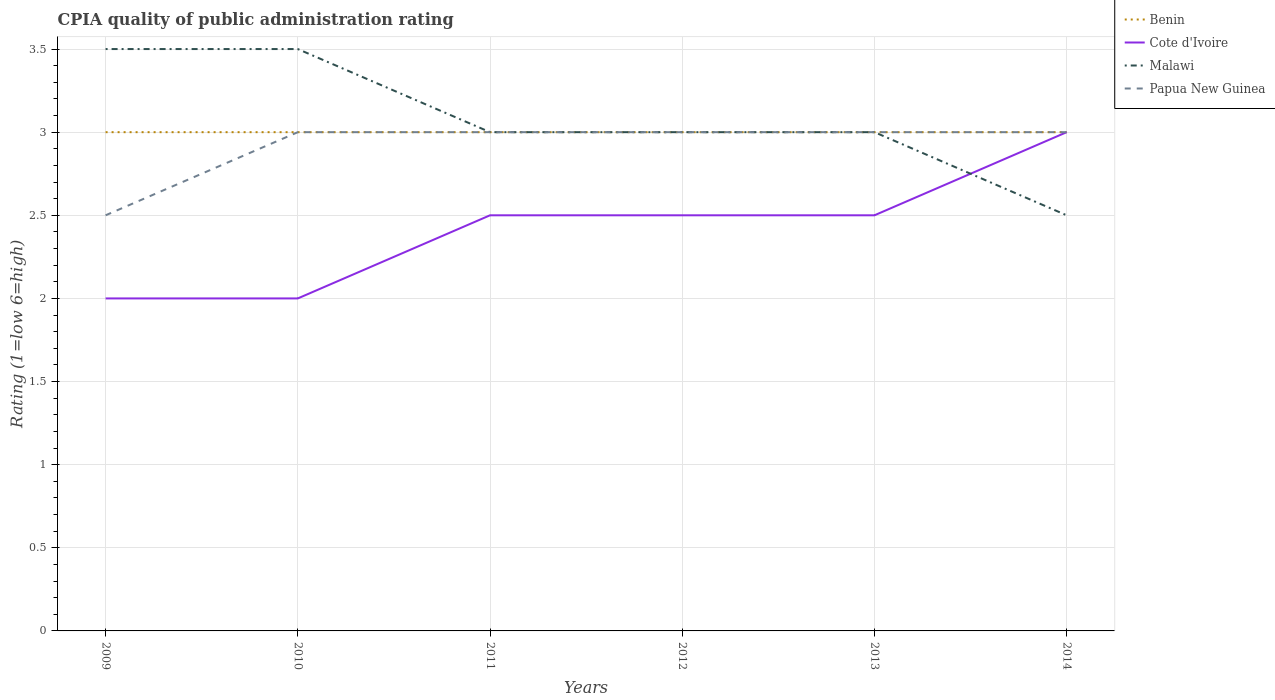How many different coloured lines are there?
Ensure brevity in your answer.  4. Does the line corresponding to Benin intersect with the line corresponding to Papua New Guinea?
Your answer should be compact. Yes. Across all years, what is the maximum CPIA rating in Cote d'Ivoire?
Offer a terse response. 2. In which year was the CPIA rating in Cote d'Ivoire maximum?
Provide a short and direct response. 2009. What is the total CPIA rating in Cote d'Ivoire in the graph?
Keep it short and to the point. -0.5. What is the difference between the highest and the lowest CPIA rating in Papua New Guinea?
Provide a short and direct response. 5. Is the CPIA rating in Papua New Guinea strictly greater than the CPIA rating in Malawi over the years?
Your response must be concise. No. How many lines are there?
Make the answer very short. 4. What is the difference between two consecutive major ticks on the Y-axis?
Your answer should be compact. 0.5. Does the graph contain grids?
Offer a terse response. Yes. Where does the legend appear in the graph?
Keep it short and to the point. Top right. How are the legend labels stacked?
Give a very brief answer. Vertical. What is the title of the graph?
Offer a terse response. CPIA quality of public administration rating. Does "United Arab Emirates" appear as one of the legend labels in the graph?
Provide a succinct answer. No. What is the label or title of the Y-axis?
Your answer should be compact. Rating (1=low 6=high). What is the Rating (1=low 6=high) of Malawi in 2009?
Provide a succinct answer. 3.5. What is the Rating (1=low 6=high) in Benin in 2010?
Offer a terse response. 3. What is the Rating (1=low 6=high) of Malawi in 2010?
Provide a short and direct response. 3.5. What is the Rating (1=low 6=high) in Papua New Guinea in 2010?
Ensure brevity in your answer.  3. What is the Rating (1=low 6=high) in Cote d'Ivoire in 2011?
Keep it short and to the point. 2.5. What is the Rating (1=low 6=high) of Cote d'Ivoire in 2012?
Ensure brevity in your answer.  2.5. What is the Rating (1=low 6=high) of Papua New Guinea in 2012?
Ensure brevity in your answer.  3. What is the Rating (1=low 6=high) in Papua New Guinea in 2013?
Make the answer very short. 3. What is the Rating (1=low 6=high) of Cote d'Ivoire in 2014?
Offer a terse response. 3. What is the Rating (1=low 6=high) in Malawi in 2014?
Your response must be concise. 2.5. What is the Rating (1=low 6=high) of Papua New Guinea in 2014?
Keep it short and to the point. 3. Across all years, what is the maximum Rating (1=low 6=high) in Benin?
Make the answer very short. 3. Across all years, what is the maximum Rating (1=low 6=high) of Cote d'Ivoire?
Your response must be concise. 3. Across all years, what is the maximum Rating (1=low 6=high) in Malawi?
Keep it short and to the point. 3.5. Across all years, what is the maximum Rating (1=low 6=high) of Papua New Guinea?
Your response must be concise. 3. Across all years, what is the minimum Rating (1=low 6=high) of Benin?
Make the answer very short. 3. Across all years, what is the minimum Rating (1=low 6=high) in Malawi?
Your response must be concise. 2.5. What is the total Rating (1=low 6=high) of Papua New Guinea in the graph?
Provide a short and direct response. 17.5. What is the difference between the Rating (1=low 6=high) in Cote d'Ivoire in 2009 and that in 2010?
Ensure brevity in your answer.  0. What is the difference between the Rating (1=low 6=high) of Malawi in 2009 and that in 2010?
Give a very brief answer. 0. What is the difference between the Rating (1=low 6=high) of Malawi in 2009 and that in 2012?
Keep it short and to the point. 0.5. What is the difference between the Rating (1=low 6=high) in Papua New Guinea in 2009 and that in 2012?
Make the answer very short. -0.5. What is the difference between the Rating (1=low 6=high) of Cote d'Ivoire in 2009 and that in 2013?
Ensure brevity in your answer.  -0.5. What is the difference between the Rating (1=low 6=high) in Malawi in 2009 and that in 2013?
Offer a very short reply. 0.5. What is the difference between the Rating (1=low 6=high) in Papua New Guinea in 2009 and that in 2013?
Provide a succinct answer. -0.5. What is the difference between the Rating (1=low 6=high) in Benin in 2009 and that in 2014?
Offer a very short reply. 0. What is the difference between the Rating (1=low 6=high) in Cote d'Ivoire in 2009 and that in 2014?
Make the answer very short. -1. What is the difference between the Rating (1=low 6=high) in Papua New Guinea in 2009 and that in 2014?
Ensure brevity in your answer.  -0.5. What is the difference between the Rating (1=low 6=high) of Benin in 2010 and that in 2011?
Offer a terse response. 0. What is the difference between the Rating (1=low 6=high) in Cote d'Ivoire in 2010 and that in 2011?
Your answer should be very brief. -0.5. What is the difference between the Rating (1=low 6=high) of Malawi in 2010 and that in 2011?
Your answer should be compact. 0.5. What is the difference between the Rating (1=low 6=high) in Cote d'Ivoire in 2010 and that in 2012?
Your answer should be compact. -0.5. What is the difference between the Rating (1=low 6=high) of Papua New Guinea in 2010 and that in 2012?
Keep it short and to the point. 0. What is the difference between the Rating (1=low 6=high) in Benin in 2010 and that in 2013?
Provide a short and direct response. 0. What is the difference between the Rating (1=low 6=high) of Malawi in 2010 and that in 2013?
Provide a short and direct response. 0.5. What is the difference between the Rating (1=low 6=high) in Papua New Guinea in 2010 and that in 2013?
Make the answer very short. 0. What is the difference between the Rating (1=low 6=high) in Benin in 2010 and that in 2014?
Your answer should be compact. 0. What is the difference between the Rating (1=low 6=high) of Cote d'Ivoire in 2010 and that in 2014?
Ensure brevity in your answer.  -1. What is the difference between the Rating (1=low 6=high) in Papua New Guinea in 2010 and that in 2014?
Keep it short and to the point. 0. What is the difference between the Rating (1=low 6=high) in Malawi in 2011 and that in 2012?
Offer a terse response. 0. What is the difference between the Rating (1=low 6=high) of Papua New Guinea in 2011 and that in 2012?
Provide a short and direct response. 0. What is the difference between the Rating (1=low 6=high) in Benin in 2011 and that in 2013?
Provide a short and direct response. 0. What is the difference between the Rating (1=low 6=high) in Cote d'Ivoire in 2011 and that in 2013?
Offer a very short reply. 0. What is the difference between the Rating (1=low 6=high) in Papua New Guinea in 2011 and that in 2013?
Give a very brief answer. 0. What is the difference between the Rating (1=low 6=high) in Benin in 2011 and that in 2014?
Make the answer very short. 0. What is the difference between the Rating (1=low 6=high) in Papua New Guinea in 2011 and that in 2014?
Your answer should be very brief. 0. What is the difference between the Rating (1=low 6=high) in Cote d'Ivoire in 2012 and that in 2014?
Your response must be concise. -0.5. What is the difference between the Rating (1=low 6=high) in Malawi in 2012 and that in 2014?
Ensure brevity in your answer.  0.5. What is the difference between the Rating (1=low 6=high) of Cote d'Ivoire in 2013 and that in 2014?
Your response must be concise. -0.5. What is the difference between the Rating (1=low 6=high) of Malawi in 2013 and that in 2014?
Keep it short and to the point. 0.5. What is the difference between the Rating (1=low 6=high) of Papua New Guinea in 2013 and that in 2014?
Offer a terse response. 0. What is the difference between the Rating (1=low 6=high) of Benin in 2009 and the Rating (1=low 6=high) of Cote d'Ivoire in 2010?
Offer a very short reply. 1. What is the difference between the Rating (1=low 6=high) in Benin in 2009 and the Rating (1=low 6=high) in Malawi in 2010?
Offer a terse response. -0.5. What is the difference between the Rating (1=low 6=high) of Benin in 2009 and the Rating (1=low 6=high) of Papua New Guinea in 2010?
Give a very brief answer. 0. What is the difference between the Rating (1=low 6=high) of Cote d'Ivoire in 2009 and the Rating (1=low 6=high) of Papua New Guinea in 2010?
Provide a succinct answer. -1. What is the difference between the Rating (1=low 6=high) of Malawi in 2009 and the Rating (1=low 6=high) of Papua New Guinea in 2010?
Offer a terse response. 0.5. What is the difference between the Rating (1=low 6=high) of Benin in 2009 and the Rating (1=low 6=high) of Malawi in 2012?
Provide a short and direct response. 0. What is the difference between the Rating (1=low 6=high) of Benin in 2009 and the Rating (1=low 6=high) of Papua New Guinea in 2012?
Your answer should be very brief. 0. What is the difference between the Rating (1=low 6=high) in Cote d'Ivoire in 2009 and the Rating (1=low 6=high) in Malawi in 2012?
Make the answer very short. -1. What is the difference between the Rating (1=low 6=high) of Benin in 2009 and the Rating (1=low 6=high) of Cote d'Ivoire in 2013?
Ensure brevity in your answer.  0.5. What is the difference between the Rating (1=low 6=high) in Benin in 2009 and the Rating (1=low 6=high) in Malawi in 2013?
Offer a very short reply. 0. What is the difference between the Rating (1=low 6=high) in Cote d'Ivoire in 2009 and the Rating (1=low 6=high) in Papua New Guinea in 2013?
Provide a succinct answer. -1. What is the difference between the Rating (1=low 6=high) in Benin in 2009 and the Rating (1=low 6=high) in Malawi in 2014?
Provide a short and direct response. 0.5. What is the difference between the Rating (1=low 6=high) of Benin in 2009 and the Rating (1=low 6=high) of Papua New Guinea in 2014?
Provide a succinct answer. 0. What is the difference between the Rating (1=low 6=high) of Malawi in 2009 and the Rating (1=low 6=high) of Papua New Guinea in 2014?
Ensure brevity in your answer.  0.5. What is the difference between the Rating (1=low 6=high) of Benin in 2010 and the Rating (1=low 6=high) of Cote d'Ivoire in 2011?
Keep it short and to the point. 0.5. What is the difference between the Rating (1=low 6=high) of Malawi in 2010 and the Rating (1=low 6=high) of Papua New Guinea in 2011?
Offer a terse response. 0.5. What is the difference between the Rating (1=low 6=high) in Benin in 2010 and the Rating (1=low 6=high) in Cote d'Ivoire in 2012?
Offer a very short reply. 0.5. What is the difference between the Rating (1=low 6=high) in Benin in 2010 and the Rating (1=low 6=high) in Malawi in 2012?
Your response must be concise. 0. What is the difference between the Rating (1=low 6=high) in Benin in 2010 and the Rating (1=low 6=high) in Papua New Guinea in 2012?
Provide a succinct answer. 0. What is the difference between the Rating (1=low 6=high) in Malawi in 2010 and the Rating (1=low 6=high) in Papua New Guinea in 2012?
Your response must be concise. 0.5. What is the difference between the Rating (1=low 6=high) in Benin in 2010 and the Rating (1=low 6=high) in Cote d'Ivoire in 2013?
Make the answer very short. 0.5. What is the difference between the Rating (1=low 6=high) in Benin in 2010 and the Rating (1=low 6=high) in Malawi in 2013?
Make the answer very short. 0. What is the difference between the Rating (1=low 6=high) of Cote d'Ivoire in 2010 and the Rating (1=low 6=high) of Malawi in 2013?
Keep it short and to the point. -1. What is the difference between the Rating (1=low 6=high) of Benin in 2010 and the Rating (1=low 6=high) of Malawi in 2014?
Provide a short and direct response. 0.5. What is the difference between the Rating (1=low 6=high) in Cote d'Ivoire in 2010 and the Rating (1=low 6=high) in Papua New Guinea in 2014?
Give a very brief answer. -1. What is the difference between the Rating (1=low 6=high) in Cote d'Ivoire in 2011 and the Rating (1=low 6=high) in Malawi in 2012?
Give a very brief answer. -0.5. What is the difference between the Rating (1=low 6=high) in Malawi in 2011 and the Rating (1=low 6=high) in Papua New Guinea in 2012?
Offer a terse response. 0. What is the difference between the Rating (1=low 6=high) of Cote d'Ivoire in 2011 and the Rating (1=low 6=high) of Malawi in 2013?
Your answer should be very brief. -0.5. What is the difference between the Rating (1=low 6=high) in Cote d'Ivoire in 2011 and the Rating (1=low 6=high) in Papua New Guinea in 2013?
Provide a short and direct response. -0.5. What is the difference between the Rating (1=low 6=high) of Malawi in 2011 and the Rating (1=low 6=high) of Papua New Guinea in 2013?
Provide a succinct answer. 0. What is the difference between the Rating (1=low 6=high) in Benin in 2011 and the Rating (1=low 6=high) in Cote d'Ivoire in 2014?
Make the answer very short. 0. What is the difference between the Rating (1=low 6=high) in Benin in 2011 and the Rating (1=low 6=high) in Papua New Guinea in 2014?
Your answer should be very brief. 0. What is the difference between the Rating (1=low 6=high) in Malawi in 2011 and the Rating (1=low 6=high) in Papua New Guinea in 2014?
Offer a terse response. 0. What is the difference between the Rating (1=low 6=high) in Benin in 2012 and the Rating (1=low 6=high) in Cote d'Ivoire in 2013?
Your answer should be compact. 0.5. What is the difference between the Rating (1=low 6=high) in Benin in 2012 and the Rating (1=low 6=high) in Papua New Guinea in 2013?
Make the answer very short. 0. What is the difference between the Rating (1=low 6=high) of Cote d'Ivoire in 2012 and the Rating (1=low 6=high) of Papua New Guinea in 2013?
Offer a very short reply. -0.5. What is the difference between the Rating (1=low 6=high) of Benin in 2012 and the Rating (1=low 6=high) of Cote d'Ivoire in 2014?
Your answer should be very brief. 0. What is the difference between the Rating (1=low 6=high) of Benin in 2012 and the Rating (1=low 6=high) of Malawi in 2014?
Give a very brief answer. 0.5. What is the difference between the Rating (1=low 6=high) in Benin in 2012 and the Rating (1=low 6=high) in Papua New Guinea in 2014?
Your response must be concise. 0. What is the difference between the Rating (1=low 6=high) in Cote d'Ivoire in 2012 and the Rating (1=low 6=high) in Malawi in 2014?
Ensure brevity in your answer.  0. What is the difference between the Rating (1=low 6=high) of Benin in 2013 and the Rating (1=low 6=high) of Cote d'Ivoire in 2014?
Provide a succinct answer. 0. What is the average Rating (1=low 6=high) in Benin per year?
Offer a very short reply. 3. What is the average Rating (1=low 6=high) of Cote d'Ivoire per year?
Offer a terse response. 2.42. What is the average Rating (1=low 6=high) of Malawi per year?
Your answer should be compact. 3.08. What is the average Rating (1=low 6=high) in Papua New Guinea per year?
Give a very brief answer. 2.92. In the year 2009, what is the difference between the Rating (1=low 6=high) of Benin and Rating (1=low 6=high) of Malawi?
Offer a very short reply. -0.5. In the year 2009, what is the difference between the Rating (1=low 6=high) of Cote d'Ivoire and Rating (1=low 6=high) of Malawi?
Keep it short and to the point. -1.5. In the year 2009, what is the difference between the Rating (1=low 6=high) of Cote d'Ivoire and Rating (1=low 6=high) of Papua New Guinea?
Offer a very short reply. -0.5. In the year 2009, what is the difference between the Rating (1=low 6=high) of Malawi and Rating (1=low 6=high) of Papua New Guinea?
Your response must be concise. 1. In the year 2010, what is the difference between the Rating (1=low 6=high) of Benin and Rating (1=low 6=high) of Cote d'Ivoire?
Offer a terse response. 1. In the year 2010, what is the difference between the Rating (1=low 6=high) of Cote d'Ivoire and Rating (1=low 6=high) of Malawi?
Provide a succinct answer. -1.5. In the year 2010, what is the difference between the Rating (1=low 6=high) of Cote d'Ivoire and Rating (1=low 6=high) of Papua New Guinea?
Your response must be concise. -1. In the year 2010, what is the difference between the Rating (1=low 6=high) in Malawi and Rating (1=low 6=high) in Papua New Guinea?
Make the answer very short. 0.5. In the year 2011, what is the difference between the Rating (1=low 6=high) of Benin and Rating (1=low 6=high) of Papua New Guinea?
Ensure brevity in your answer.  0. In the year 2011, what is the difference between the Rating (1=low 6=high) in Cote d'Ivoire and Rating (1=low 6=high) in Malawi?
Your answer should be compact. -0.5. In the year 2012, what is the difference between the Rating (1=low 6=high) in Benin and Rating (1=low 6=high) in Malawi?
Your answer should be compact. 0. In the year 2012, what is the difference between the Rating (1=low 6=high) of Benin and Rating (1=low 6=high) of Papua New Guinea?
Make the answer very short. 0. In the year 2012, what is the difference between the Rating (1=low 6=high) of Cote d'Ivoire and Rating (1=low 6=high) of Malawi?
Keep it short and to the point. -0.5. In the year 2012, what is the difference between the Rating (1=low 6=high) in Cote d'Ivoire and Rating (1=low 6=high) in Papua New Guinea?
Provide a short and direct response. -0.5. In the year 2013, what is the difference between the Rating (1=low 6=high) in Benin and Rating (1=low 6=high) in Cote d'Ivoire?
Your answer should be very brief. 0.5. In the year 2013, what is the difference between the Rating (1=low 6=high) in Benin and Rating (1=low 6=high) in Malawi?
Make the answer very short. 0. In the year 2013, what is the difference between the Rating (1=low 6=high) in Benin and Rating (1=low 6=high) in Papua New Guinea?
Your answer should be very brief. 0. In the year 2013, what is the difference between the Rating (1=low 6=high) in Cote d'Ivoire and Rating (1=low 6=high) in Malawi?
Make the answer very short. -0.5. In the year 2013, what is the difference between the Rating (1=low 6=high) in Cote d'Ivoire and Rating (1=low 6=high) in Papua New Guinea?
Provide a short and direct response. -0.5. In the year 2013, what is the difference between the Rating (1=low 6=high) in Malawi and Rating (1=low 6=high) in Papua New Guinea?
Give a very brief answer. 0. In the year 2014, what is the difference between the Rating (1=low 6=high) of Benin and Rating (1=low 6=high) of Malawi?
Ensure brevity in your answer.  0.5. In the year 2014, what is the difference between the Rating (1=low 6=high) in Cote d'Ivoire and Rating (1=low 6=high) in Malawi?
Your answer should be very brief. 0.5. In the year 2014, what is the difference between the Rating (1=low 6=high) in Malawi and Rating (1=low 6=high) in Papua New Guinea?
Offer a terse response. -0.5. What is the ratio of the Rating (1=low 6=high) in Cote d'Ivoire in 2009 to that in 2010?
Give a very brief answer. 1. What is the ratio of the Rating (1=low 6=high) of Papua New Guinea in 2009 to that in 2010?
Keep it short and to the point. 0.83. What is the ratio of the Rating (1=low 6=high) in Cote d'Ivoire in 2009 to that in 2011?
Your answer should be compact. 0.8. What is the ratio of the Rating (1=low 6=high) in Malawi in 2009 to that in 2011?
Provide a succinct answer. 1.17. What is the ratio of the Rating (1=low 6=high) of Papua New Guinea in 2009 to that in 2011?
Give a very brief answer. 0.83. What is the ratio of the Rating (1=low 6=high) in Malawi in 2009 to that in 2012?
Provide a short and direct response. 1.17. What is the ratio of the Rating (1=low 6=high) in Malawi in 2009 to that in 2013?
Provide a short and direct response. 1.17. What is the ratio of the Rating (1=low 6=high) of Papua New Guinea in 2009 to that in 2013?
Ensure brevity in your answer.  0.83. What is the ratio of the Rating (1=low 6=high) of Benin in 2010 to that in 2011?
Provide a succinct answer. 1. What is the ratio of the Rating (1=low 6=high) of Cote d'Ivoire in 2010 to that in 2011?
Make the answer very short. 0.8. What is the ratio of the Rating (1=low 6=high) of Papua New Guinea in 2010 to that in 2011?
Provide a succinct answer. 1. What is the ratio of the Rating (1=low 6=high) of Benin in 2010 to that in 2012?
Make the answer very short. 1. What is the ratio of the Rating (1=low 6=high) in Malawi in 2010 to that in 2012?
Ensure brevity in your answer.  1.17. What is the ratio of the Rating (1=low 6=high) in Cote d'Ivoire in 2010 to that in 2013?
Make the answer very short. 0.8. What is the ratio of the Rating (1=low 6=high) in Malawi in 2010 to that in 2013?
Offer a terse response. 1.17. What is the ratio of the Rating (1=low 6=high) of Benin in 2010 to that in 2014?
Give a very brief answer. 1. What is the ratio of the Rating (1=low 6=high) in Malawi in 2010 to that in 2014?
Keep it short and to the point. 1.4. What is the ratio of the Rating (1=low 6=high) of Papua New Guinea in 2010 to that in 2014?
Your answer should be compact. 1. What is the ratio of the Rating (1=low 6=high) of Malawi in 2011 to that in 2012?
Your response must be concise. 1. What is the ratio of the Rating (1=low 6=high) of Benin in 2011 to that in 2013?
Your response must be concise. 1. What is the ratio of the Rating (1=low 6=high) of Cote d'Ivoire in 2011 to that in 2013?
Your response must be concise. 1. What is the ratio of the Rating (1=low 6=high) in Papua New Guinea in 2011 to that in 2013?
Ensure brevity in your answer.  1. What is the ratio of the Rating (1=low 6=high) in Benin in 2011 to that in 2014?
Your answer should be very brief. 1. What is the ratio of the Rating (1=low 6=high) of Cote d'Ivoire in 2011 to that in 2014?
Your answer should be compact. 0.83. What is the ratio of the Rating (1=low 6=high) of Malawi in 2011 to that in 2014?
Keep it short and to the point. 1.2. What is the ratio of the Rating (1=low 6=high) of Benin in 2012 to that in 2013?
Your answer should be compact. 1. What is the ratio of the Rating (1=low 6=high) of Cote d'Ivoire in 2012 to that in 2013?
Offer a very short reply. 1. What is the ratio of the Rating (1=low 6=high) in Malawi in 2012 to that in 2013?
Provide a succinct answer. 1. What is the ratio of the Rating (1=low 6=high) in Benin in 2012 to that in 2014?
Your answer should be compact. 1. What is the ratio of the Rating (1=low 6=high) in Cote d'Ivoire in 2013 to that in 2014?
Keep it short and to the point. 0.83. What is the ratio of the Rating (1=low 6=high) in Malawi in 2013 to that in 2014?
Make the answer very short. 1.2. What is the ratio of the Rating (1=low 6=high) in Papua New Guinea in 2013 to that in 2014?
Keep it short and to the point. 1. What is the difference between the highest and the second highest Rating (1=low 6=high) in Cote d'Ivoire?
Your answer should be compact. 0.5. What is the difference between the highest and the second highest Rating (1=low 6=high) in Malawi?
Your response must be concise. 0. What is the difference between the highest and the second highest Rating (1=low 6=high) of Papua New Guinea?
Give a very brief answer. 0. What is the difference between the highest and the lowest Rating (1=low 6=high) in Benin?
Keep it short and to the point. 0. What is the difference between the highest and the lowest Rating (1=low 6=high) in Malawi?
Your answer should be very brief. 1. What is the difference between the highest and the lowest Rating (1=low 6=high) in Papua New Guinea?
Your response must be concise. 0.5. 